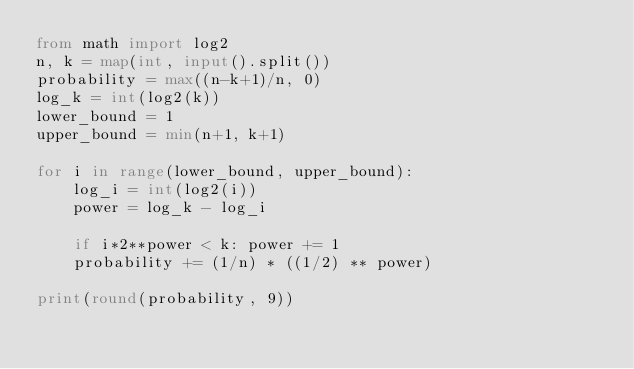Convert code to text. <code><loc_0><loc_0><loc_500><loc_500><_Python_>from math import log2
n, k = map(int, input().split())
probability = max((n-k+1)/n, 0)
log_k = int(log2(k))
lower_bound = 1
upper_bound = min(n+1, k+1)

for i in range(lower_bound, upper_bound):
    log_i = int(log2(i))
    power = log_k - log_i

    if i*2**power < k: power += 1
    probability += (1/n) * ((1/2) ** power)

print(round(probability, 9))</code> 